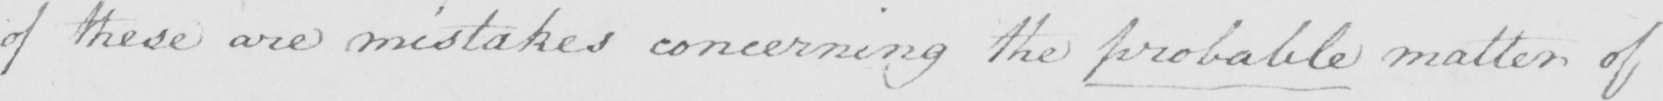Please transcribe the handwritten text in this image. of these are mistakes concerning the probable matter of 